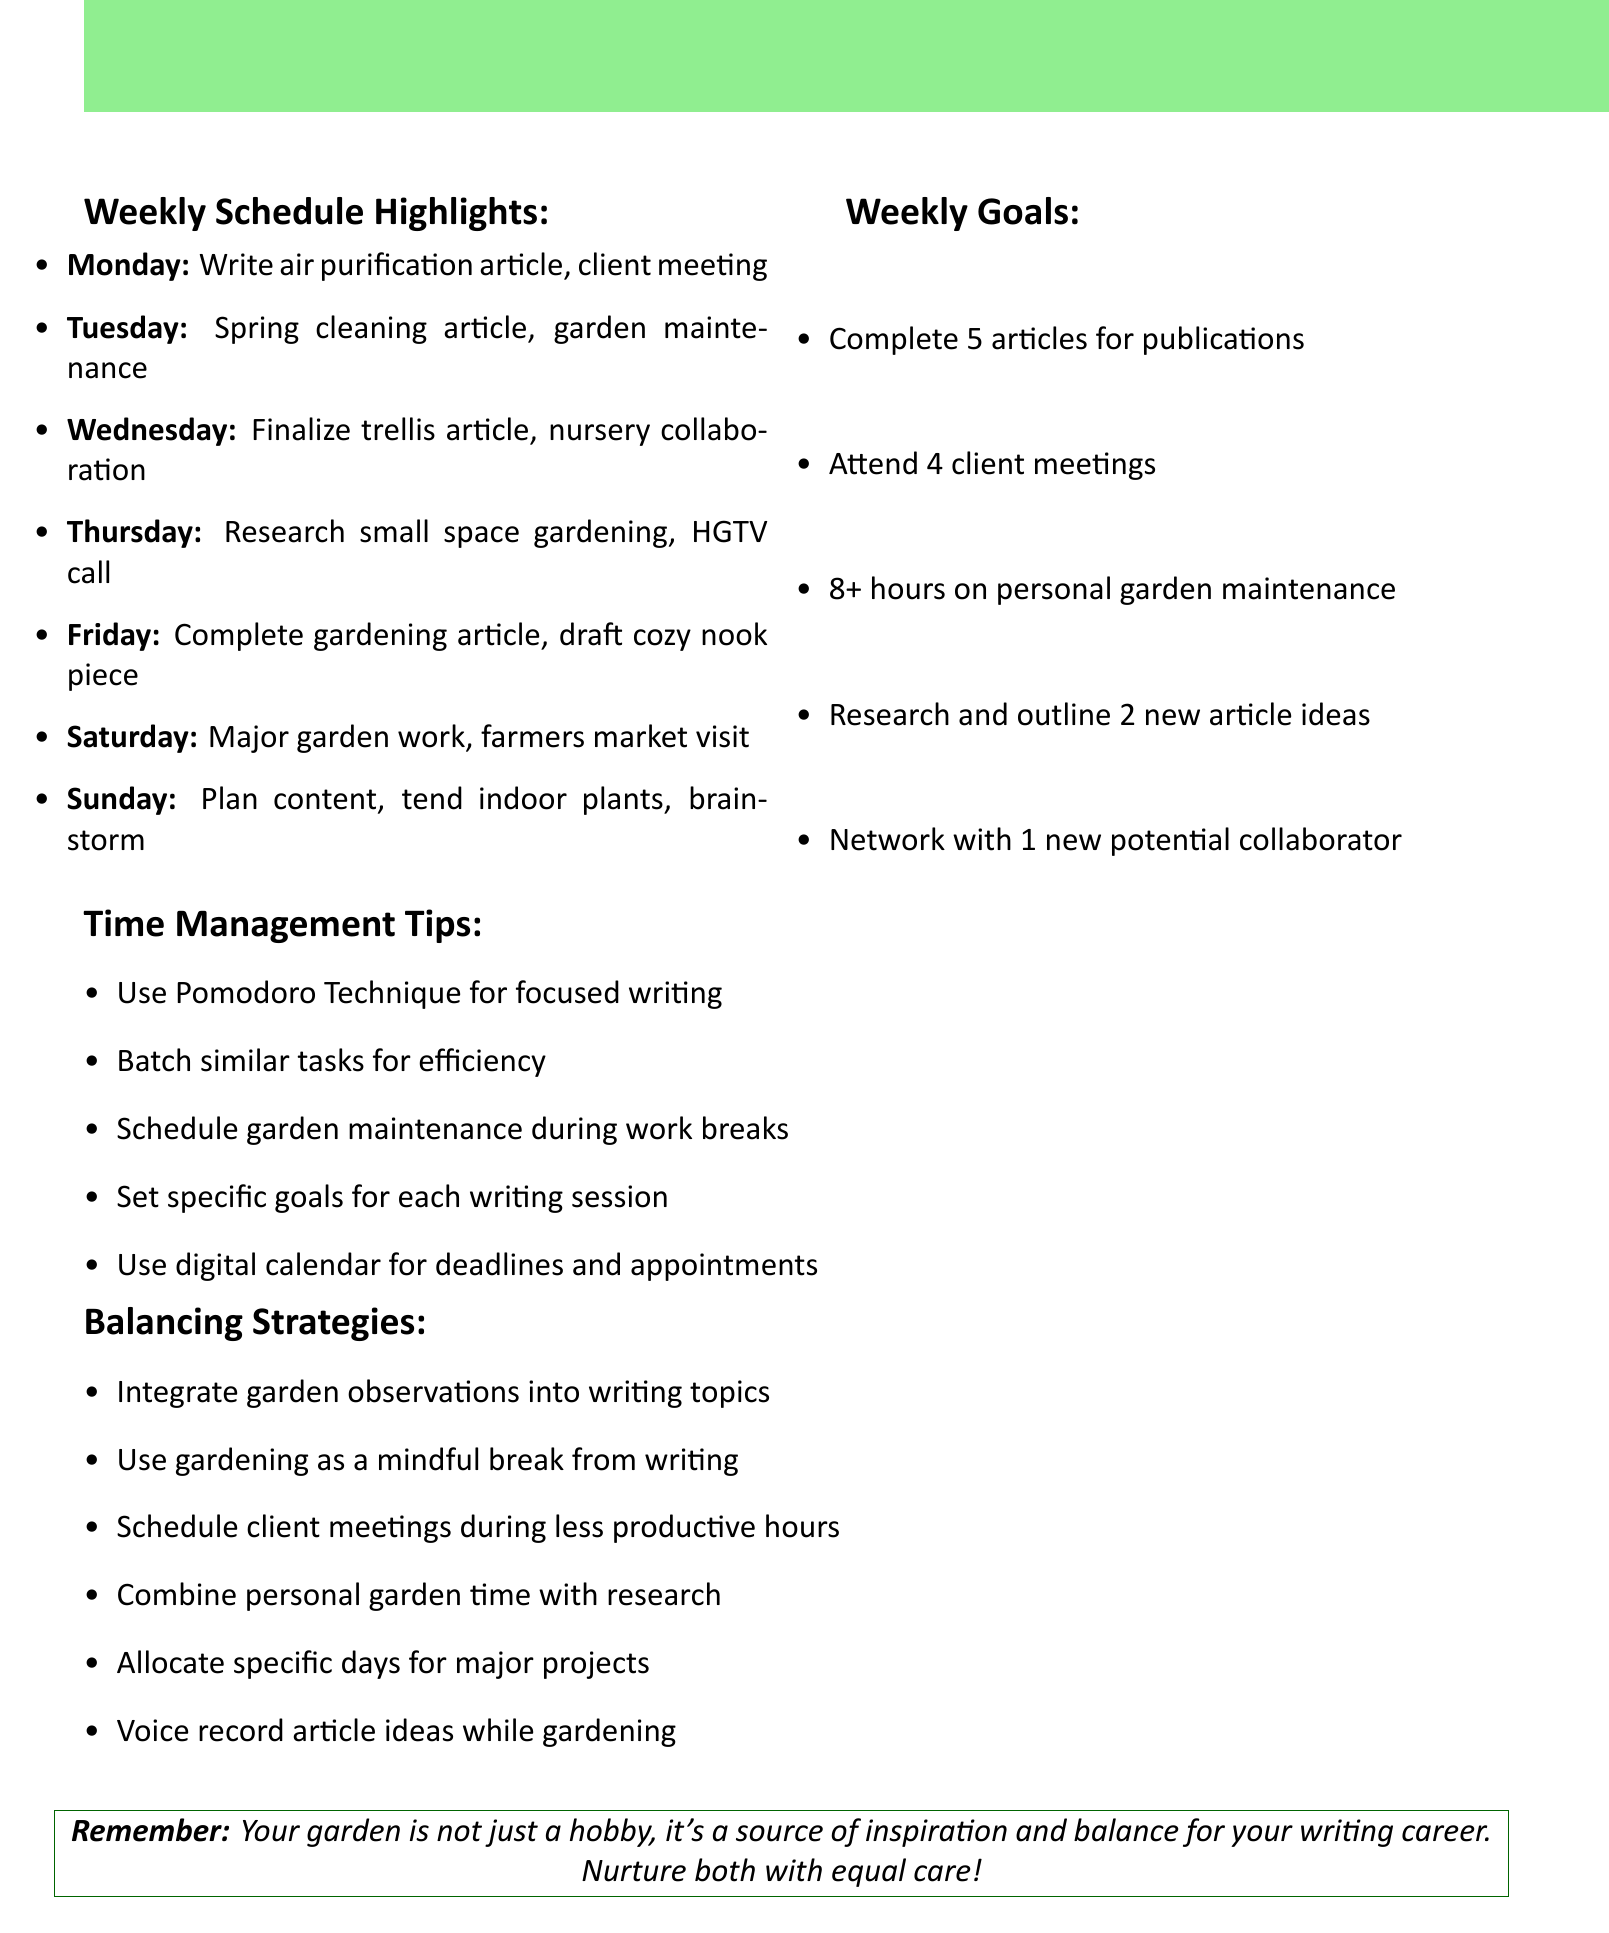What is the main theme of the agenda? The main theme of the agenda revolves around balancing writing projects and personal garden maintenance throughout the week.
Answer: Balancing writing & gardening How many articles are to be completed during the week? The weekly goals mention completing 5 articles for various publications as a target for the week.
Answer: 5 articles What day is dedicated to major garden maintenance? Saturday is the day dedicated to major garden maintenance tasks such as mowing, edging, and pruning.
Answer: Saturday Which client meeting is scheduled on Monday? The document specifies a client meeting with Better Homes & Gardens magazine scheduled on Monday from 11:30 AM to 12:30 PM.
Answer: Better Homes & Gardens What time is allocated for brainstorming new article ideas on Sunday? Brainstorming new article ideas and researching trending topics are scheduled from 2:00 PM to 4:00 PM on Sunday.
Answer: 2:00 PM - 4:00 PM What is one of the time management tips provided in the document? The document lists various time management tips, such as using the Pomodoro Technique for focused writing sessions.
Answer: Pomodoro Technique How many client meetings are set for the week? The weekly goals state that there are 4 client meetings to be attended throughout the week.
Answer: 4 meetings What is one of the balancing strategies suggested? The document encourages integrating garden observations into writing topics for inspiration as a balancing strategy.
Answer: Integrate garden observations What day is reserved for visiting the local farmers market? The schedule indicates that visiting the local farmers market for article inspiration is planned for Saturday.
Answer: Saturday 